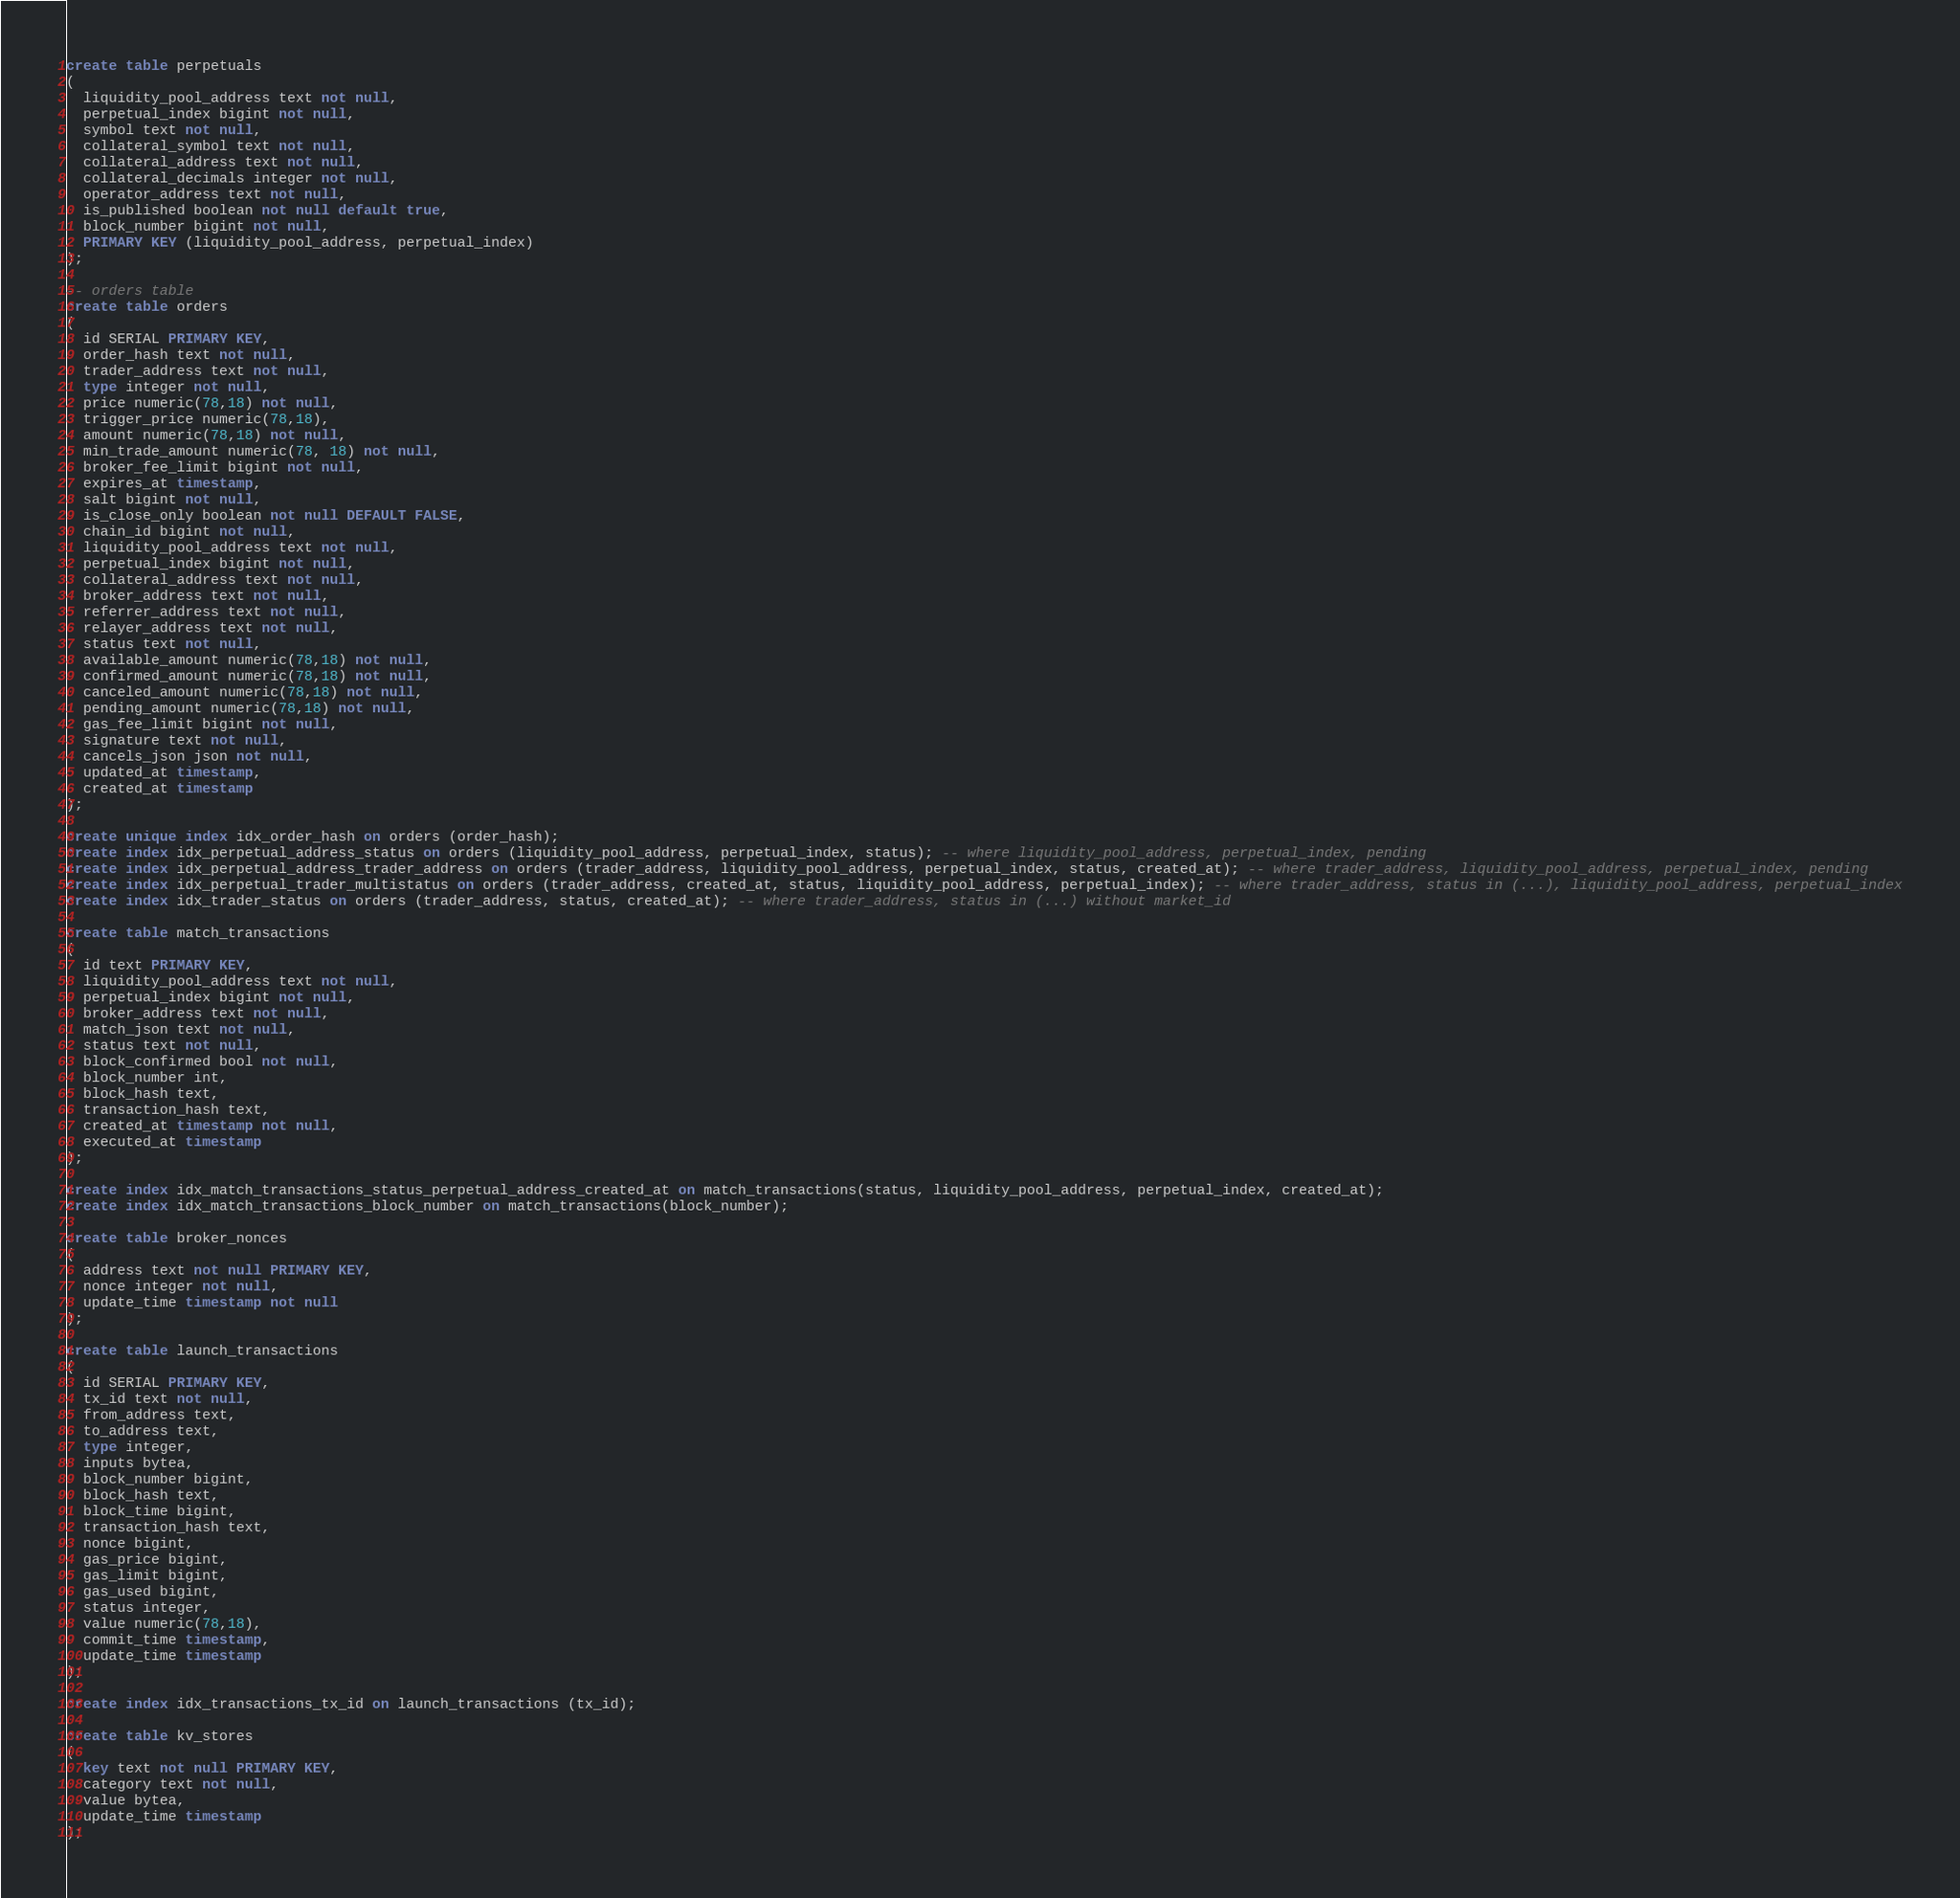<code> <loc_0><loc_0><loc_500><loc_500><_SQL_>create table perpetuals
(
  liquidity_pool_address text not null,
  perpetual_index bigint not null,
  symbol text not null,
  collateral_symbol text not null,
  collateral_address text not null,
  collateral_decimals integer not null,
  operator_address text not null,
  is_published boolean not null default true,
  block_number bigint not null,
  PRIMARY KEY (liquidity_pool_address, perpetual_index)
);

-- orders table
create table orders
(
  id SERIAL PRIMARY KEY,
  order_hash text not null,
  trader_address text not null,
  type integer not null,
  price numeric(78,18) not null,
  trigger_price numeric(78,18),
  amount numeric(78,18) not null,
  min_trade_amount numeric(78, 18) not null,
  broker_fee_limit bigint not null,
  expires_at timestamp,
  salt bigint not null,
  is_close_only boolean not null DEFAULT FALSE,
  chain_id bigint not null,
  liquidity_pool_address text not null,
  perpetual_index bigint not null,
  collateral_address text not null,
  broker_address text not null,
  referrer_address text not null,
  relayer_address text not null,
  status text not null,
  available_amount numeric(78,18) not null,
  confirmed_amount numeric(78,18) not null,
  canceled_amount numeric(78,18) not null,
  pending_amount numeric(78,18) not null,
  gas_fee_limit bigint not null,
  signature text not null,
  cancels_json json not null,
  updated_at timestamp,
  created_at timestamp
);

create unique index idx_order_hash on orders (order_hash);
create index idx_perpetual_address_status on orders (liquidity_pool_address, perpetual_index, status); -- where liquidity_pool_address, perpetual_index, pending
create index idx_perpetual_address_trader_address on orders (trader_address, liquidity_pool_address, perpetual_index, status, created_at); -- where trader_address, liquidity_pool_address, perpetual_index, pending
create index idx_perpetual_trader_multistatus on orders (trader_address, created_at, status, liquidity_pool_address, perpetual_index); -- where trader_address, status in (...), liquidity_pool_address, perpetual_index
create index idx_trader_status on orders (trader_address, status, created_at); -- where trader_address, status in (...) without market_id

create table match_transactions
(
  id text PRIMARY KEY,
  liquidity_pool_address text not null,
  perpetual_index bigint not null,
  broker_address text not null,
  match_json text not null,
  status text not null,
  block_confirmed bool not null,
  block_number int,
  block_hash text,
  transaction_hash text,
  created_at timestamp not null,
  executed_at timestamp
);

create index idx_match_transactions_status_perpetual_address_created_at on match_transactions(status, liquidity_pool_address, perpetual_index, created_at);
create index idx_match_transactions_block_number on match_transactions(block_number);

create table broker_nonces
(
  address text not null PRIMARY KEY,
  nonce integer not null,
  update_time timestamp not null
);

create table launch_transactions
(
  id SERIAL PRIMARY KEY,
  tx_id text not null,
  from_address text,
  to_address text,
  type integer,
  inputs bytea,
  block_number bigint,
  block_hash text,
  block_time bigint,
  transaction_hash text,
  nonce bigint,
  gas_price bigint,
  gas_limit bigint,
  gas_used bigint,
  status integer,
  value numeric(78,18),
  commit_time timestamp,
  update_time timestamp
);

create index idx_transactions_tx_id on launch_transactions (tx_id);

create table kv_stores
(
  key text not null PRIMARY KEY,
  category text not null,
  value bytea,
  update_time timestamp
);</code> 